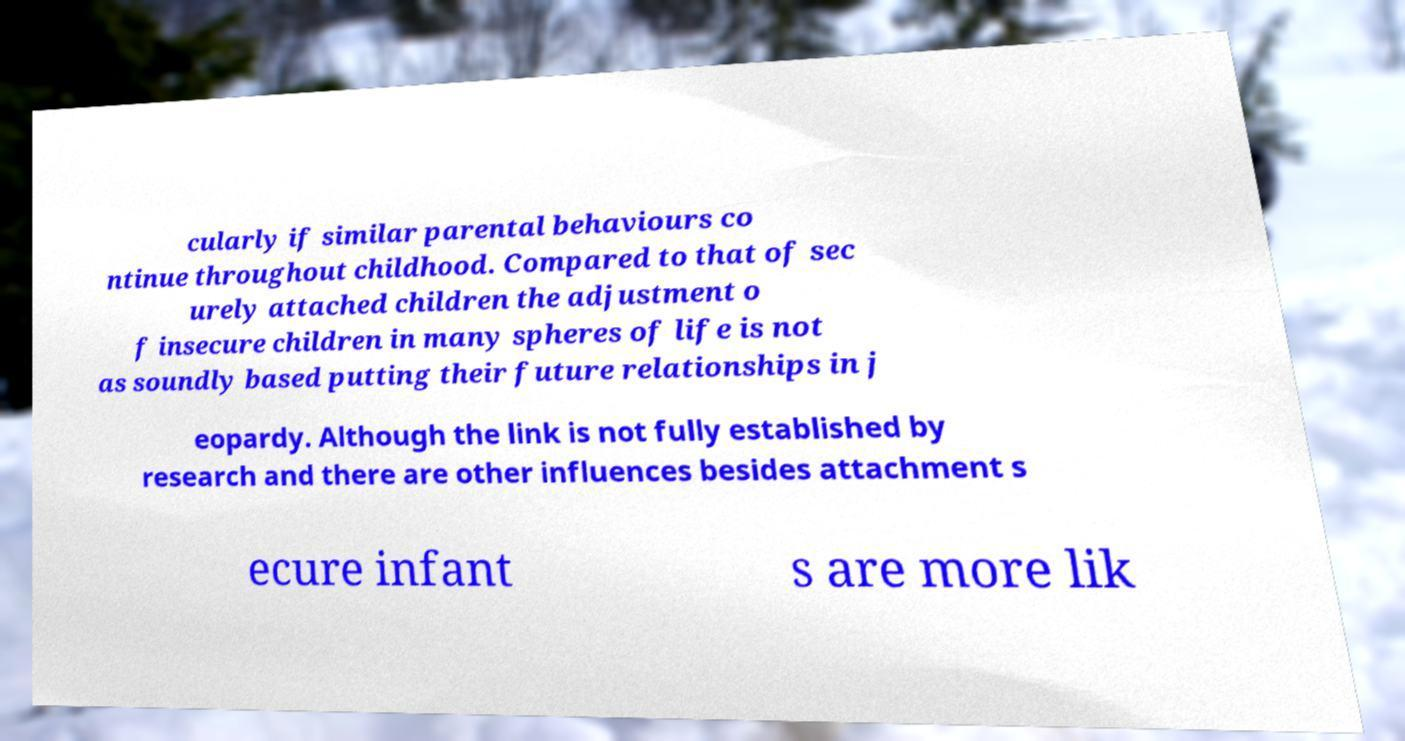Please identify and transcribe the text found in this image. cularly if similar parental behaviours co ntinue throughout childhood. Compared to that of sec urely attached children the adjustment o f insecure children in many spheres of life is not as soundly based putting their future relationships in j eopardy. Although the link is not fully established by research and there are other influences besides attachment s ecure infant s are more lik 